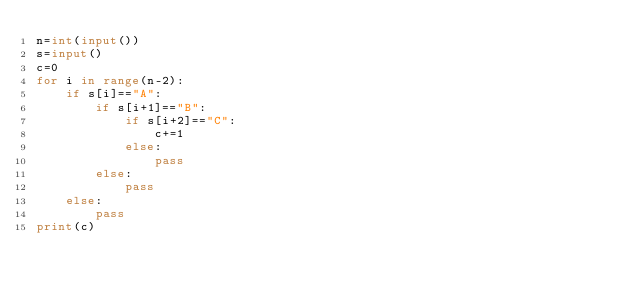<code> <loc_0><loc_0><loc_500><loc_500><_Python_>n=int(input())
s=input()
c=0
for i in range(n-2):
    if s[i]=="A":
        if s[i+1]=="B":
            if s[i+2]=="C":
                c+=1
            else:
                pass
        else:
            pass
    else:
        pass
print(c)</code> 